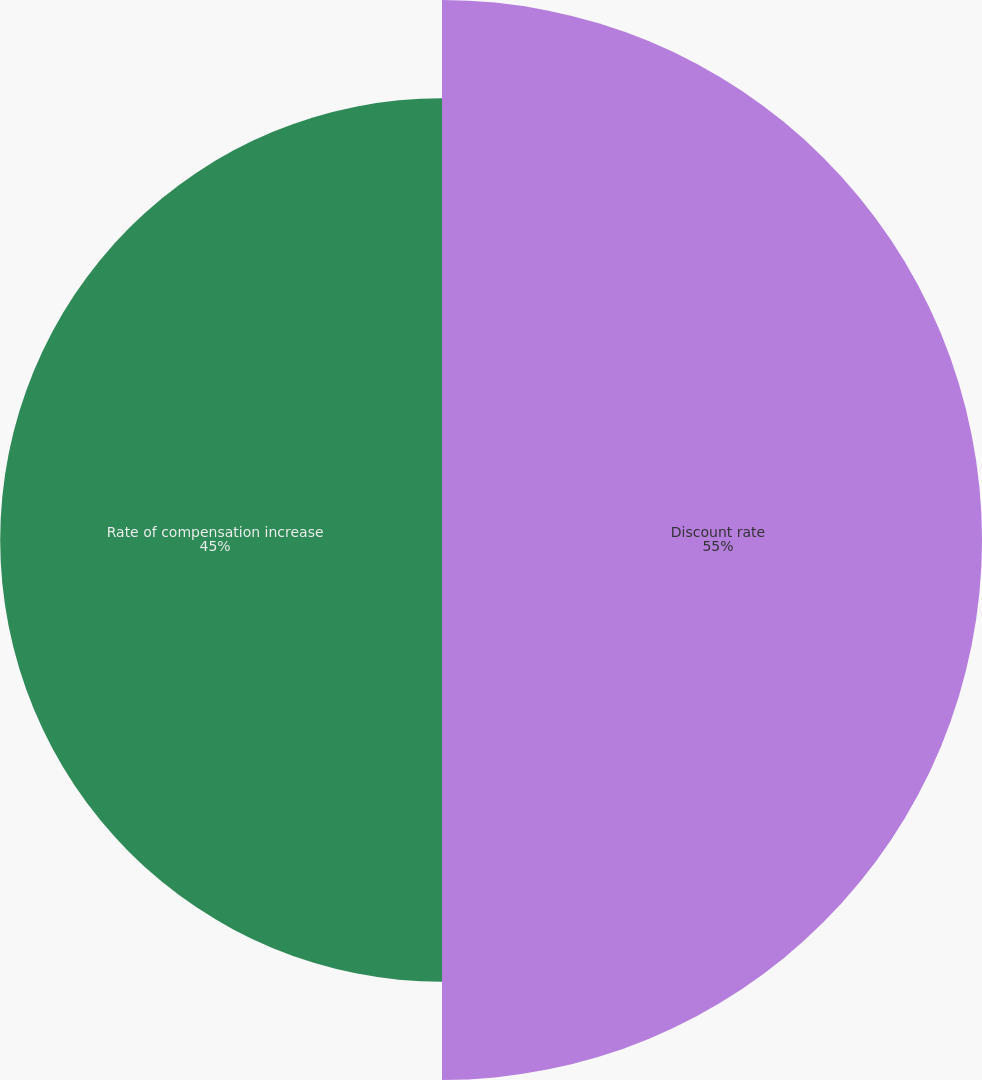<chart> <loc_0><loc_0><loc_500><loc_500><pie_chart><fcel>Discount rate<fcel>Rate of compensation increase<nl><fcel>55.0%<fcel>45.0%<nl></chart> 